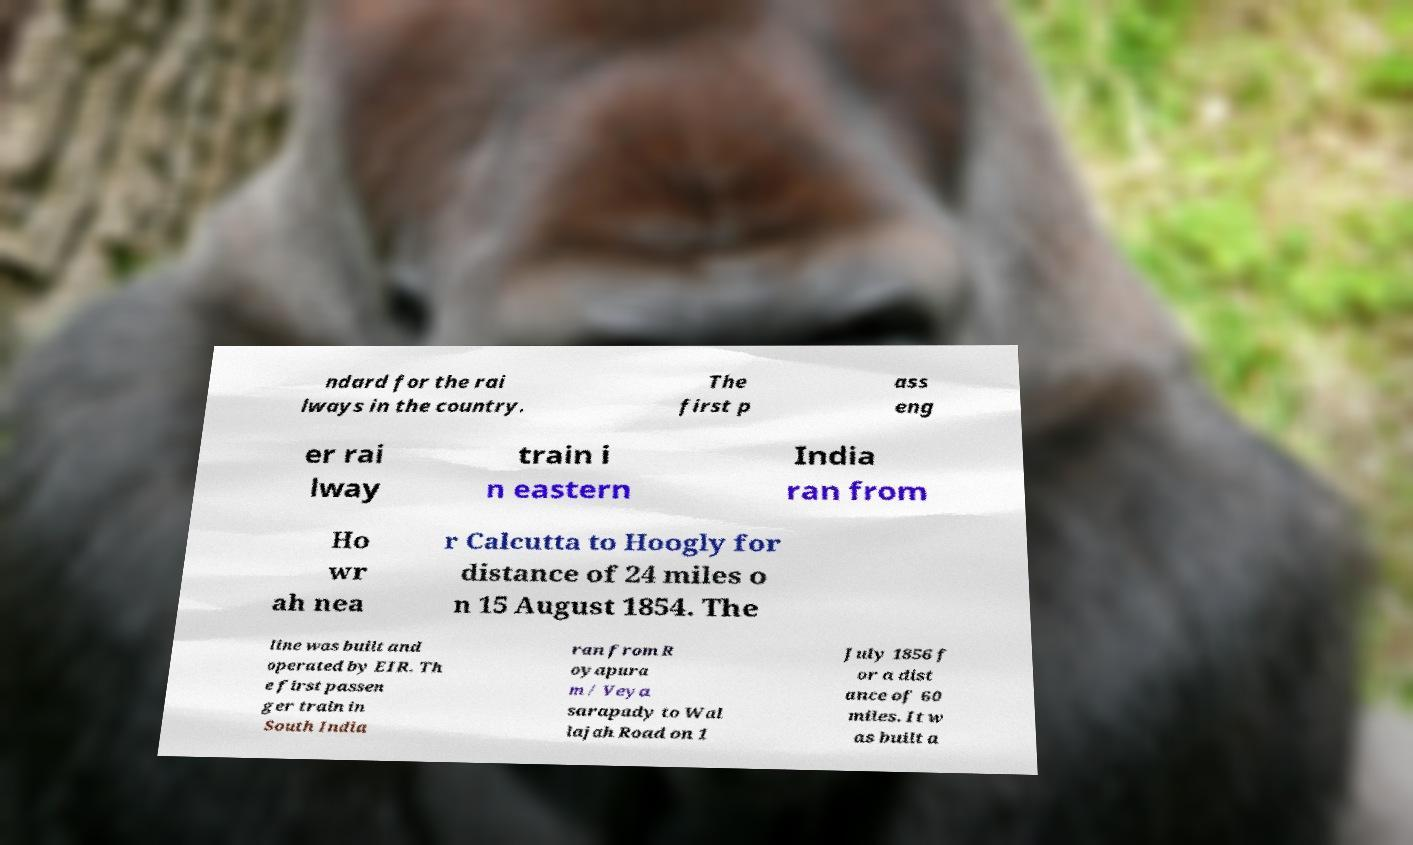Please read and relay the text visible in this image. What does it say? ndard for the rai lways in the country. The first p ass eng er rai lway train i n eastern India ran from Ho wr ah nea r Calcutta to Hoogly for distance of 24 miles o n 15 August 1854. The line was built and operated by EIR. Th e first passen ger train in South India ran from R oyapura m / Veya sarapady to Wal lajah Road on 1 July 1856 f or a dist ance of 60 miles. It w as built a 